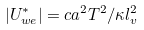Convert formula to latex. <formula><loc_0><loc_0><loc_500><loc_500>| U _ { w e } ^ { * } | = c a ^ { 2 } T ^ { 2 } / \kappa l _ { v } ^ { 2 }</formula> 